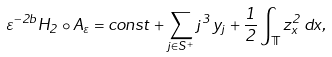Convert formula to latex. <formula><loc_0><loc_0><loc_500><loc_500>\varepsilon ^ { - 2 b } H _ { 2 } \circ A _ { \varepsilon } = c o n s t + \sum _ { j \in S ^ { + } } j ^ { 3 } \, y _ { j } + \frac { 1 } { 2 } \int _ { \mathbb { T } } z _ { x } ^ { 2 } \, d x ,</formula> 